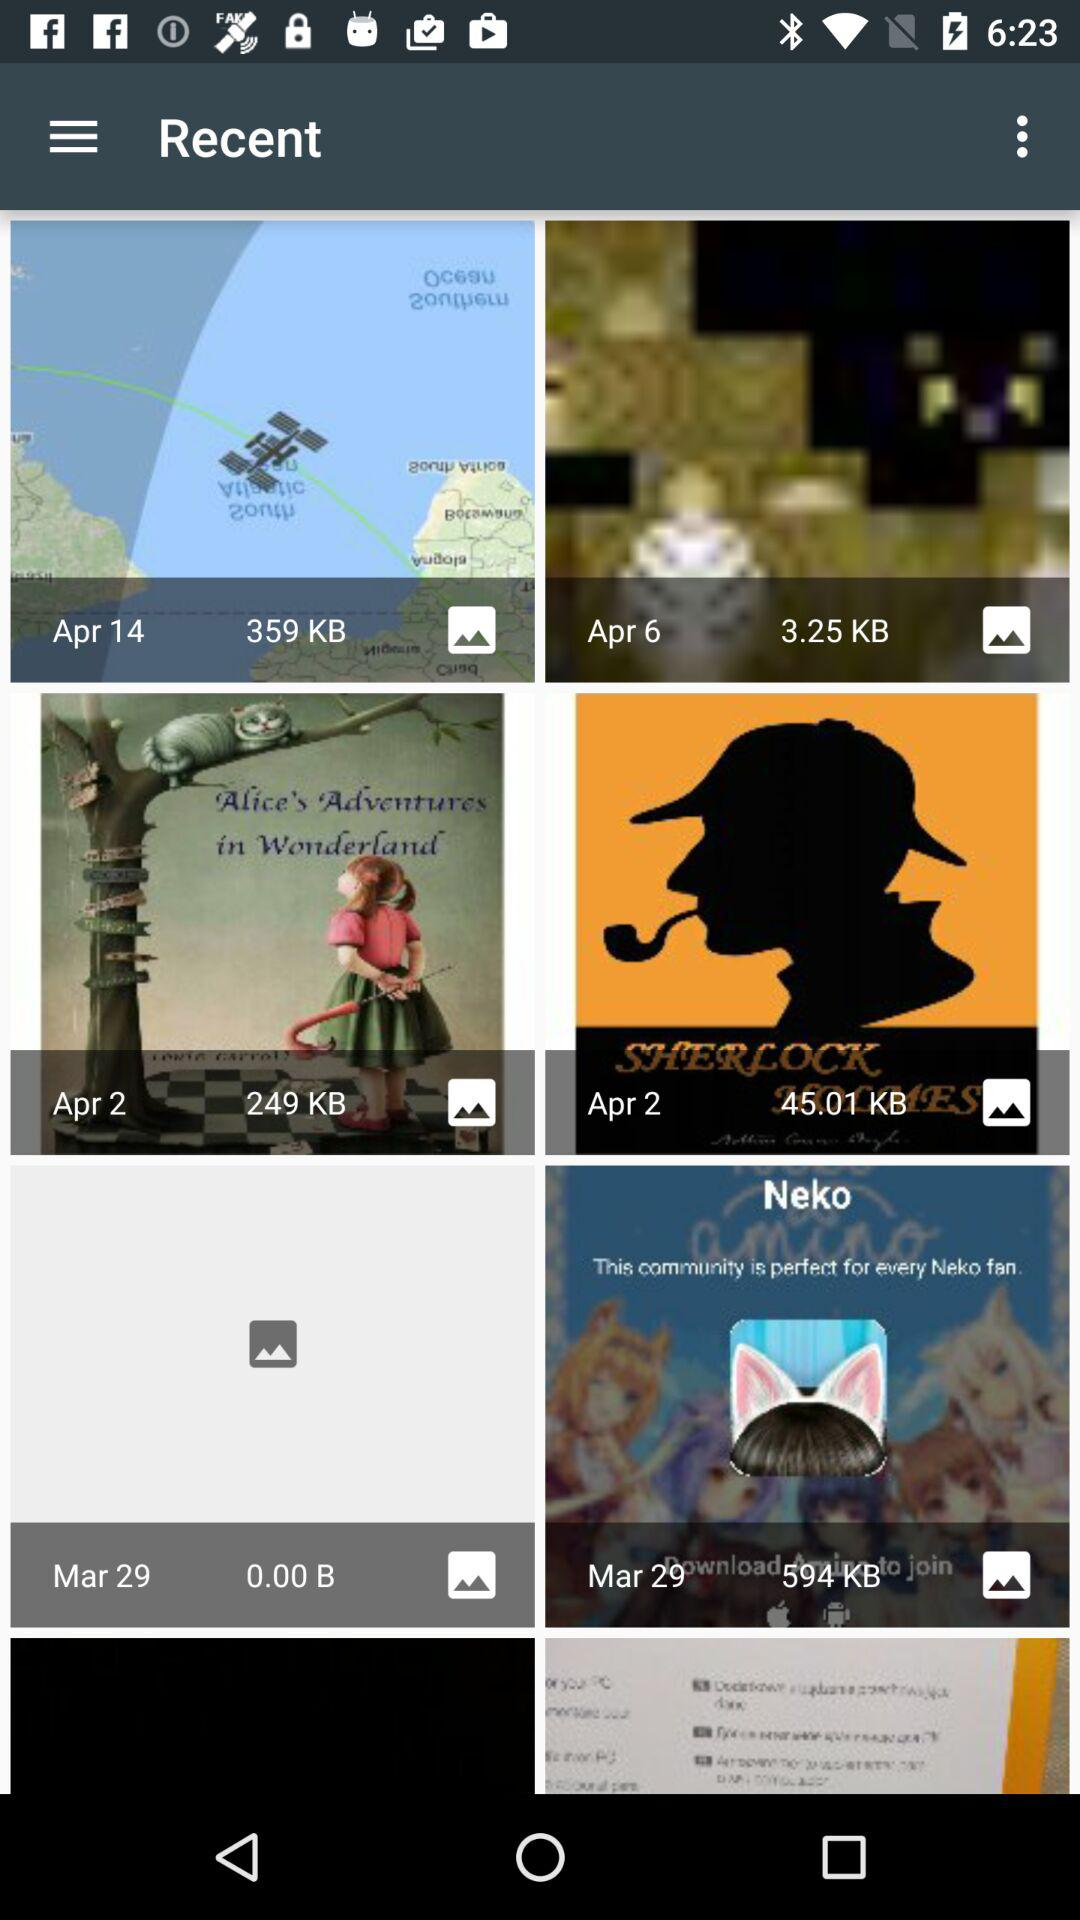On which date was the image of size 249 kb taken? The date is April 2. 